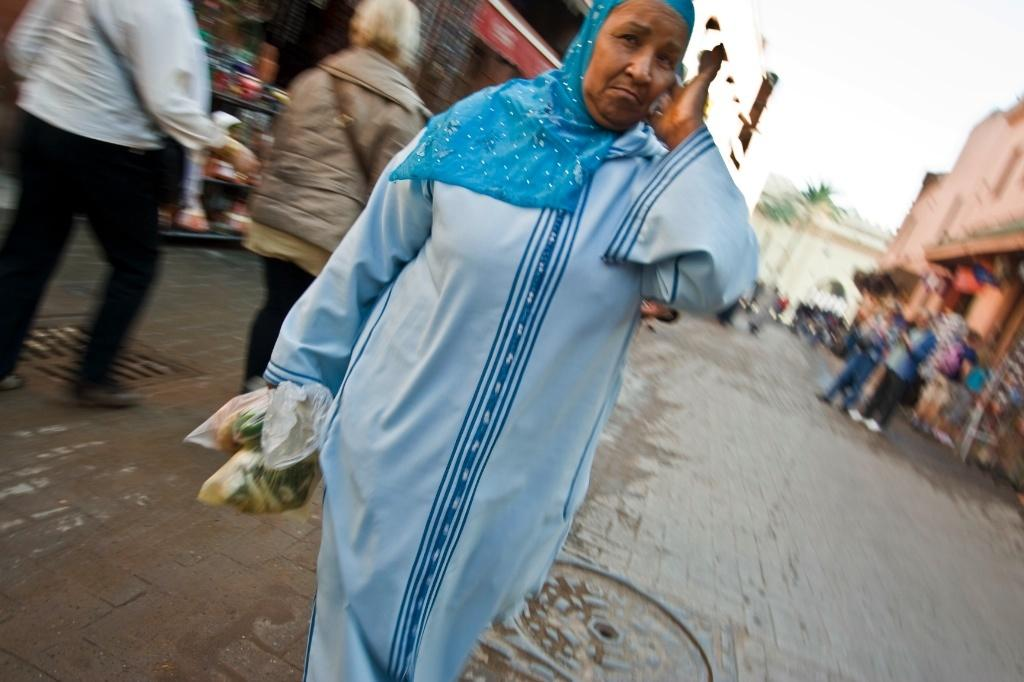Who or what can be seen in the image? There are people in the image. What type of structures are visible in the image? There are buildings in the image. What is the surface that the people and buildings are standing on? The ground is visible in the image. What color can be observed among the objects in the image? There are green colored objects in the image. What is visible above the people and buildings? The sky is visible in the image. What type of liquid can be seen dripping from the finger in the image? There is no finger or liquid present in the image. 